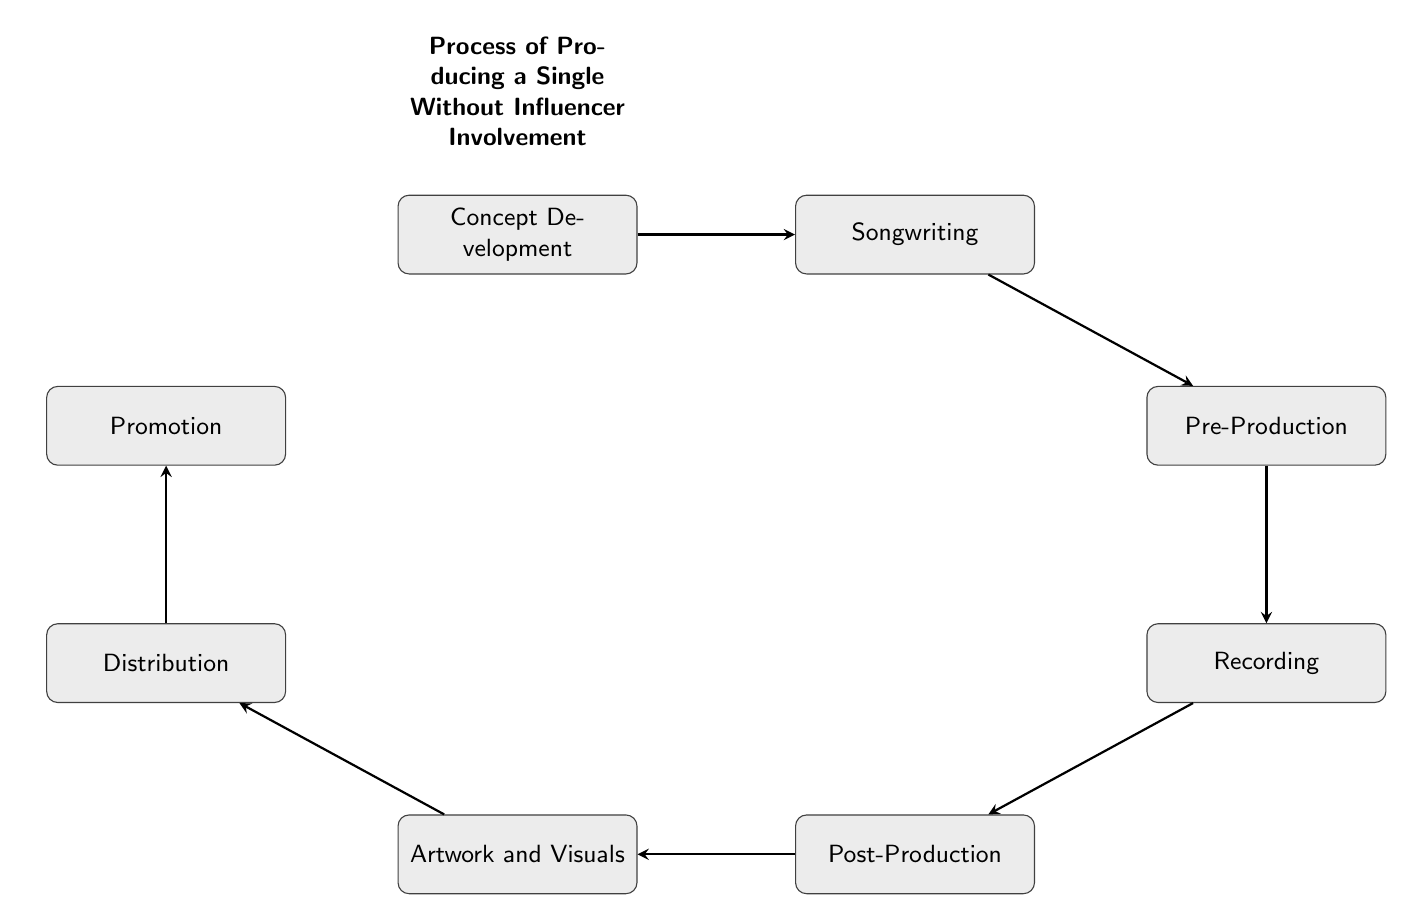What is the first step in the process? The first step is labeled "Concept Development." This is clear from the topmost node in the flow chart, which initiates the process.
Answer: Concept Development How many nodes are present in the diagram? To find the number of nodes, we count all distinct process labels in the diagram. There are eight labeled nodes that represent each step.
Answer: 8 What follows the "Recording" step? Looking at the flow chart, after the "Recording" node, the next node is "Post-Production" as indicated by the arrow connecting them.
Answer: Post-Production Which step involves designing the single’s cover art? The step that focuses on designing the cover art is labeled "Artwork and Visuals" and is found directly after "Post-Production."
Answer: Artwork and Visuals What is the last step in the process? The last node in the flow chart is "Promotion," which signifies the final stage of the process after all preceding steps have been completed.
Answer: Promotion What type of professionals are engaged for Post-Production? The description of "Post-Production" specifies that experienced audio engineers are involved, particularly those from distinguished backgrounds like Abbey Road Studios.
Answer: Experienced audio engineers What step comes after “Distribution”? The flow chart indicates that "Promotion" comes after "Distribution," as shown by the directed arrow connecting these two steps.
Answer: Promotion How does the process maintain artistic integrity during recording? According to the "Recording" node, it involves utilizing skilled studio musicians and vocalists, which helps maintain artistic integrity throughout the production process.
Answer: Skilled studio musicians and vocalists 